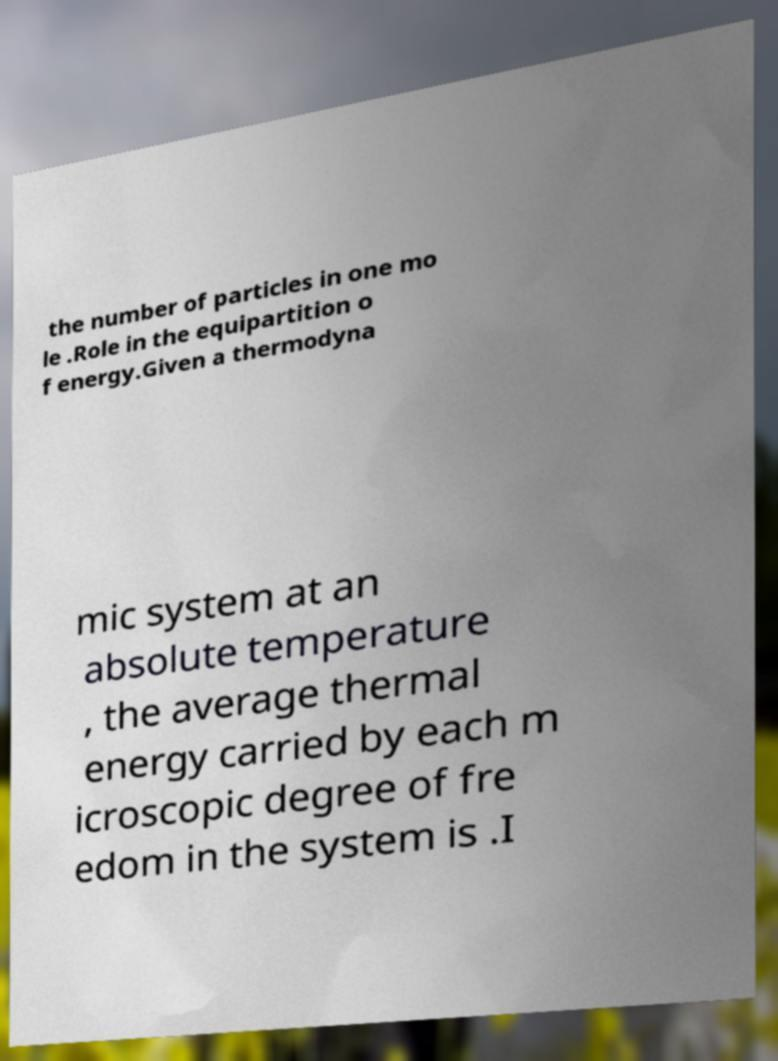I need the written content from this picture converted into text. Can you do that? the number of particles in one mo le .Role in the equipartition o f energy.Given a thermodyna mic system at an absolute temperature , the average thermal energy carried by each m icroscopic degree of fre edom in the system is .I 